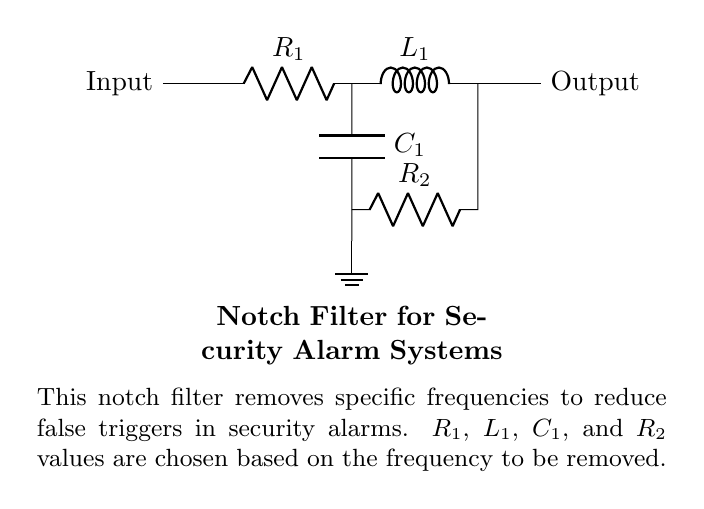What does the circuit do? The circuit is a notch filter designed to remove specific frequencies from a signal. It helps in reducing false triggers in security alarms by filtering out undesirable frequency components that may activate the alarm unnecessarily.
Answer: Notch filter What components are used in the notch filter? The components in the circuit include a resistor, an inductor, a capacitor, and another resistor. Specifically, they are labeled as R1, L1, C1, and R2, respectively, representing the primary components needed for the filtering process.
Answer: Resistor, inductor, capacitor How many resistors are present in the circuit? There are two resistors present in the circuit, identified as R1 and R2. Both of these resistors play a critical role in defining the characteristics of the notch filter.
Answer: Two What is the function of the inductor in this circuit? The inductor (L1) works by storing energy in a magnetic field when current passes through it. In the context of the notch filter, it helps to create the desired frequency response in combination with the capacitors and resistors, allowing for specific frequency attenuation.
Answer: Store energy Which component connects to the ground? The capacitor (C1) is connected to the ground in this circuit. This connection is essential for establishing a reference point for the circuit's operation and affects the filter's response characteristics.
Answer: Capacitor What is the output of the circuit labeled as? The output of the circuit is labeled as "Output," indicating where the filtered signal is taken from the notch filter, after the undesirable frequency components have been removed.
Answer: Output 